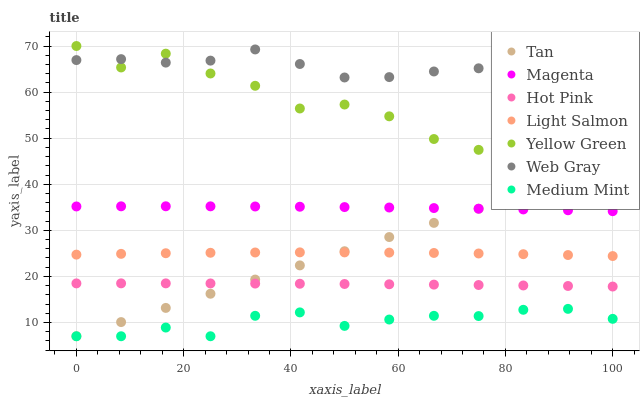Does Medium Mint have the minimum area under the curve?
Answer yes or no. Yes. Does Web Gray have the maximum area under the curve?
Answer yes or no. Yes. Does Light Salmon have the minimum area under the curve?
Answer yes or no. No. Does Light Salmon have the maximum area under the curve?
Answer yes or no. No. Is Tan the smoothest?
Answer yes or no. Yes. Is Yellow Green the roughest?
Answer yes or no. Yes. Is Light Salmon the smoothest?
Answer yes or no. No. Is Light Salmon the roughest?
Answer yes or no. No. Does Medium Mint have the lowest value?
Answer yes or no. Yes. Does Light Salmon have the lowest value?
Answer yes or no. No. Does Yellow Green have the highest value?
Answer yes or no. Yes. Does Light Salmon have the highest value?
Answer yes or no. No. Is Hot Pink less than Web Gray?
Answer yes or no. Yes. Is Web Gray greater than Light Salmon?
Answer yes or no. Yes. Does Web Gray intersect Yellow Green?
Answer yes or no. Yes. Is Web Gray less than Yellow Green?
Answer yes or no. No. Is Web Gray greater than Yellow Green?
Answer yes or no. No. Does Hot Pink intersect Web Gray?
Answer yes or no. No. 